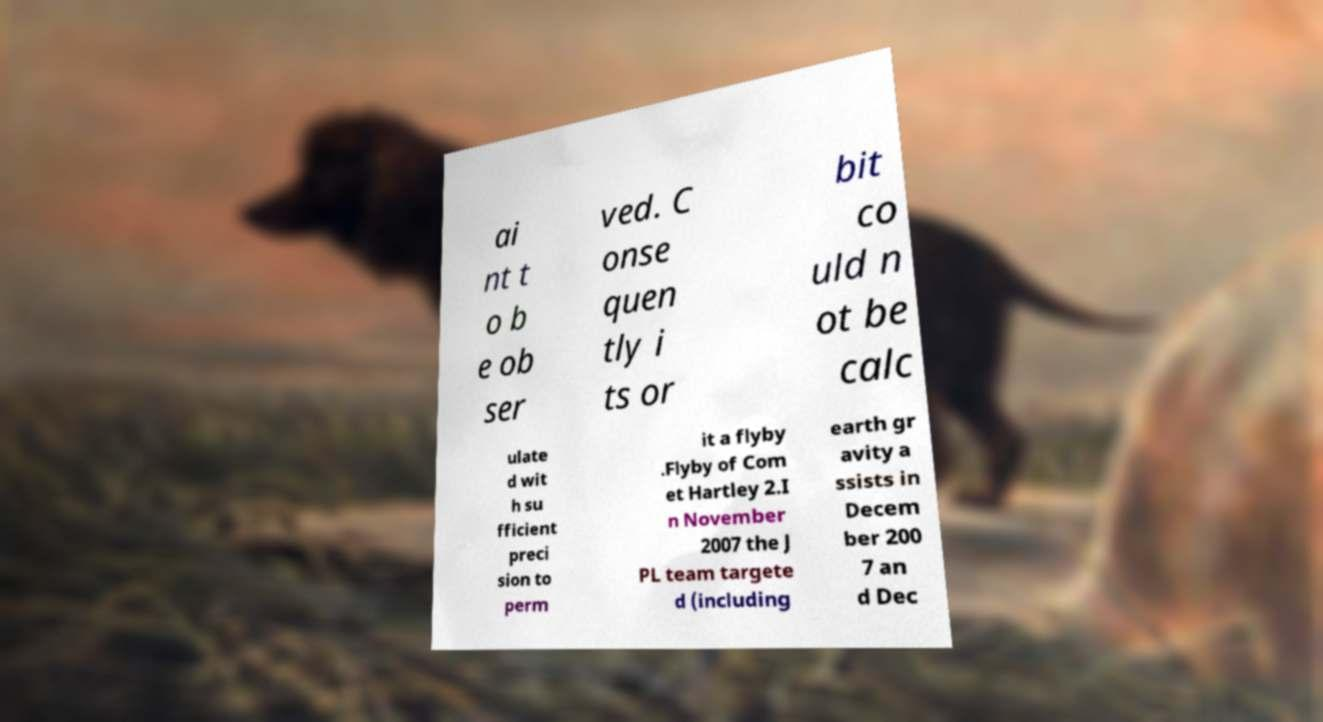I need the written content from this picture converted into text. Can you do that? ai nt t o b e ob ser ved. C onse quen tly i ts or bit co uld n ot be calc ulate d wit h su fficient preci sion to perm it a flyby .Flyby of Com et Hartley 2.I n November 2007 the J PL team targete d (including earth gr avity a ssists in Decem ber 200 7 an d Dec 